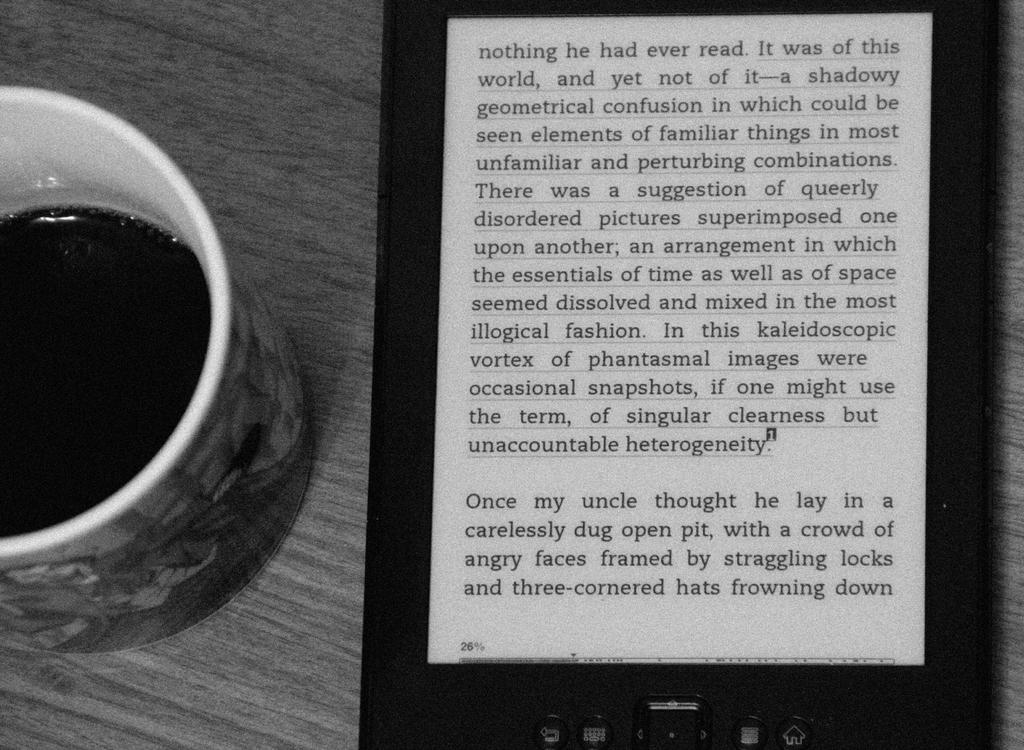What object is located on the left side of the image? There is a cup on the left side of the image. What can be seen on the right side of the image? There is a gadget on the right side of the image. How many eggs are present in the image? There are no eggs visible in the image. What type of calculator is featured on the right side of the image? There is no calculator present in the image; it features a gadget instead. 